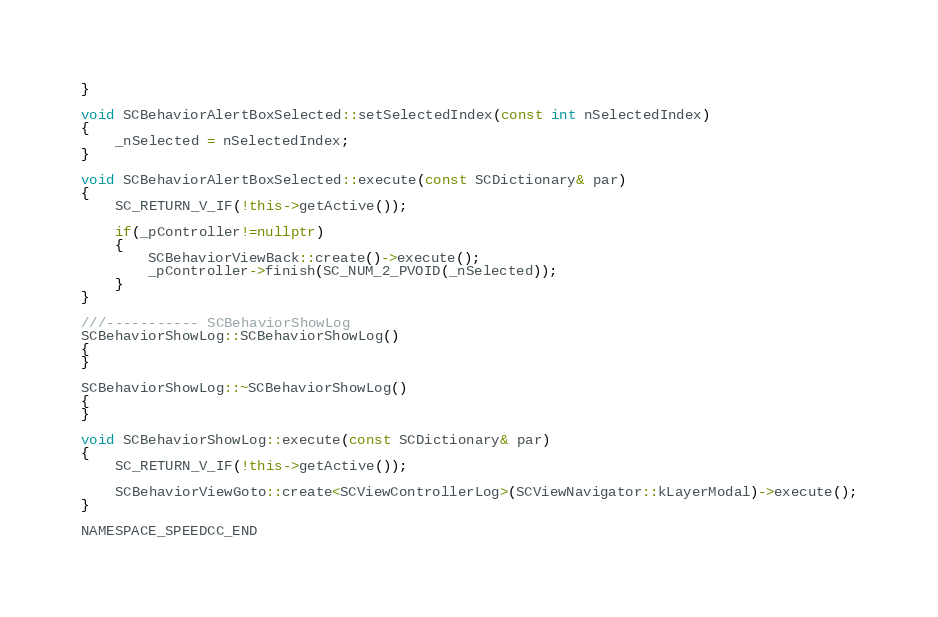<code> <loc_0><loc_0><loc_500><loc_500><_C++_>}
    
void SCBehaviorAlertBoxSelected::setSelectedIndex(const int nSelectedIndex)
{
    _nSelected = nSelectedIndex;
}
    
void SCBehaviorAlertBoxSelected::execute(const SCDictionary& par)
{
    SC_RETURN_V_IF(!this->getActive());
    
    if(_pController!=nullptr)
    {
        SCBehaviorViewBack::create()->execute();
        _pController->finish(SC_NUM_2_PVOID(_nSelected));
    }
}
    
///----------- SCBehaviorShowLog
SCBehaviorShowLog::SCBehaviorShowLog()
{
}

SCBehaviorShowLog::~SCBehaviorShowLog()
{
}

void SCBehaviorShowLog::execute(const SCDictionary& par)
{
    SC_RETURN_V_IF(!this->getActive());
    
	SCBehaviorViewGoto::create<SCViewControllerLog>(SCViewNavigator::kLayerModal)->execute();
}

NAMESPACE_SPEEDCC_END
</code> 